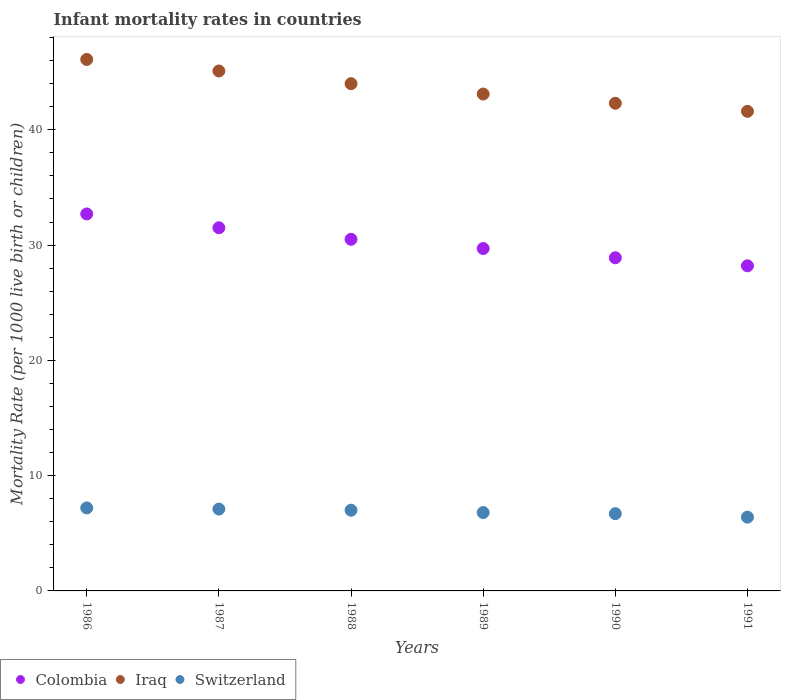What is the infant mortality rate in Colombia in 1987?
Your response must be concise. 31.5. Across all years, what is the maximum infant mortality rate in Iraq?
Give a very brief answer. 46.1. Across all years, what is the minimum infant mortality rate in Iraq?
Provide a succinct answer. 41.6. In which year was the infant mortality rate in Colombia maximum?
Offer a terse response. 1986. In which year was the infant mortality rate in Iraq minimum?
Provide a short and direct response. 1991. What is the total infant mortality rate in Switzerland in the graph?
Offer a very short reply. 41.2. What is the difference between the infant mortality rate in Iraq in 1988 and that in 1991?
Your answer should be very brief. 2.4. What is the difference between the infant mortality rate in Switzerland in 1986 and the infant mortality rate in Colombia in 1990?
Make the answer very short. -21.7. What is the average infant mortality rate in Switzerland per year?
Keep it short and to the point. 6.87. In the year 1989, what is the difference between the infant mortality rate in Colombia and infant mortality rate in Iraq?
Your answer should be very brief. -13.4. What is the ratio of the infant mortality rate in Colombia in 1986 to that in 1987?
Provide a short and direct response. 1.04. Is the infant mortality rate in Iraq in 1986 less than that in 1990?
Keep it short and to the point. No. Is the difference between the infant mortality rate in Colombia in 1986 and 1990 greater than the difference between the infant mortality rate in Iraq in 1986 and 1990?
Make the answer very short. No. What is the difference between the highest and the second highest infant mortality rate in Colombia?
Provide a succinct answer. 1.2. What is the difference between the highest and the lowest infant mortality rate in Switzerland?
Offer a very short reply. 0.8. In how many years, is the infant mortality rate in Colombia greater than the average infant mortality rate in Colombia taken over all years?
Your response must be concise. 3. Is it the case that in every year, the sum of the infant mortality rate in Iraq and infant mortality rate in Colombia  is greater than the infant mortality rate in Switzerland?
Make the answer very short. Yes. What is the difference between two consecutive major ticks on the Y-axis?
Make the answer very short. 10. Does the graph contain any zero values?
Your answer should be compact. No. Does the graph contain grids?
Offer a terse response. No. What is the title of the graph?
Your answer should be very brief. Infant mortality rates in countries. Does "French Polynesia" appear as one of the legend labels in the graph?
Your response must be concise. No. What is the label or title of the X-axis?
Your answer should be compact. Years. What is the label or title of the Y-axis?
Make the answer very short. Mortality Rate (per 1000 live birth or children). What is the Mortality Rate (per 1000 live birth or children) of Colombia in 1986?
Offer a terse response. 32.7. What is the Mortality Rate (per 1000 live birth or children) of Iraq in 1986?
Your response must be concise. 46.1. What is the Mortality Rate (per 1000 live birth or children) of Colombia in 1987?
Provide a succinct answer. 31.5. What is the Mortality Rate (per 1000 live birth or children) of Iraq in 1987?
Your response must be concise. 45.1. What is the Mortality Rate (per 1000 live birth or children) of Switzerland in 1987?
Your answer should be very brief. 7.1. What is the Mortality Rate (per 1000 live birth or children) of Colombia in 1988?
Give a very brief answer. 30.5. What is the Mortality Rate (per 1000 live birth or children) in Switzerland in 1988?
Ensure brevity in your answer.  7. What is the Mortality Rate (per 1000 live birth or children) of Colombia in 1989?
Make the answer very short. 29.7. What is the Mortality Rate (per 1000 live birth or children) of Iraq in 1989?
Your answer should be compact. 43.1. What is the Mortality Rate (per 1000 live birth or children) of Colombia in 1990?
Keep it short and to the point. 28.9. What is the Mortality Rate (per 1000 live birth or children) of Iraq in 1990?
Offer a terse response. 42.3. What is the Mortality Rate (per 1000 live birth or children) of Colombia in 1991?
Provide a short and direct response. 28.2. What is the Mortality Rate (per 1000 live birth or children) in Iraq in 1991?
Make the answer very short. 41.6. Across all years, what is the maximum Mortality Rate (per 1000 live birth or children) of Colombia?
Your answer should be very brief. 32.7. Across all years, what is the maximum Mortality Rate (per 1000 live birth or children) in Iraq?
Your answer should be compact. 46.1. Across all years, what is the minimum Mortality Rate (per 1000 live birth or children) of Colombia?
Give a very brief answer. 28.2. Across all years, what is the minimum Mortality Rate (per 1000 live birth or children) in Iraq?
Your answer should be compact. 41.6. Across all years, what is the minimum Mortality Rate (per 1000 live birth or children) of Switzerland?
Your response must be concise. 6.4. What is the total Mortality Rate (per 1000 live birth or children) of Colombia in the graph?
Offer a very short reply. 181.5. What is the total Mortality Rate (per 1000 live birth or children) of Iraq in the graph?
Make the answer very short. 262.2. What is the total Mortality Rate (per 1000 live birth or children) in Switzerland in the graph?
Provide a succinct answer. 41.2. What is the difference between the Mortality Rate (per 1000 live birth or children) in Switzerland in 1986 and that in 1987?
Your answer should be very brief. 0.1. What is the difference between the Mortality Rate (per 1000 live birth or children) of Colombia in 1986 and that in 1988?
Your answer should be compact. 2.2. What is the difference between the Mortality Rate (per 1000 live birth or children) of Iraq in 1986 and that in 1988?
Offer a very short reply. 2.1. What is the difference between the Mortality Rate (per 1000 live birth or children) of Switzerland in 1986 and that in 1988?
Keep it short and to the point. 0.2. What is the difference between the Mortality Rate (per 1000 live birth or children) in Switzerland in 1986 and that in 1990?
Provide a succinct answer. 0.5. What is the difference between the Mortality Rate (per 1000 live birth or children) of Iraq in 1986 and that in 1991?
Give a very brief answer. 4.5. What is the difference between the Mortality Rate (per 1000 live birth or children) of Switzerland in 1986 and that in 1991?
Keep it short and to the point. 0.8. What is the difference between the Mortality Rate (per 1000 live birth or children) of Iraq in 1987 and that in 1988?
Provide a succinct answer. 1.1. What is the difference between the Mortality Rate (per 1000 live birth or children) in Switzerland in 1987 and that in 1988?
Provide a short and direct response. 0.1. What is the difference between the Mortality Rate (per 1000 live birth or children) of Colombia in 1987 and that in 1989?
Offer a terse response. 1.8. What is the difference between the Mortality Rate (per 1000 live birth or children) of Iraq in 1987 and that in 1990?
Provide a short and direct response. 2.8. What is the difference between the Mortality Rate (per 1000 live birth or children) in Switzerland in 1987 and that in 1990?
Your response must be concise. 0.4. What is the difference between the Mortality Rate (per 1000 live birth or children) of Colombia in 1987 and that in 1991?
Offer a terse response. 3.3. What is the difference between the Mortality Rate (per 1000 live birth or children) of Iraq in 1987 and that in 1991?
Ensure brevity in your answer.  3.5. What is the difference between the Mortality Rate (per 1000 live birth or children) in Switzerland in 1987 and that in 1991?
Your answer should be very brief. 0.7. What is the difference between the Mortality Rate (per 1000 live birth or children) of Iraq in 1988 and that in 1991?
Give a very brief answer. 2.4. What is the difference between the Mortality Rate (per 1000 live birth or children) in Colombia in 1989 and that in 1991?
Keep it short and to the point. 1.5. What is the difference between the Mortality Rate (per 1000 live birth or children) in Iraq in 1989 and that in 1991?
Keep it short and to the point. 1.5. What is the difference between the Mortality Rate (per 1000 live birth or children) of Switzerland in 1989 and that in 1991?
Offer a very short reply. 0.4. What is the difference between the Mortality Rate (per 1000 live birth or children) in Iraq in 1990 and that in 1991?
Ensure brevity in your answer.  0.7. What is the difference between the Mortality Rate (per 1000 live birth or children) of Colombia in 1986 and the Mortality Rate (per 1000 live birth or children) of Iraq in 1987?
Make the answer very short. -12.4. What is the difference between the Mortality Rate (per 1000 live birth or children) of Colombia in 1986 and the Mortality Rate (per 1000 live birth or children) of Switzerland in 1987?
Provide a succinct answer. 25.6. What is the difference between the Mortality Rate (per 1000 live birth or children) in Colombia in 1986 and the Mortality Rate (per 1000 live birth or children) in Iraq in 1988?
Provide a short and direct response. -11.3. What is the difference between the Mortality Rate (per 1000 live birth or children) in Colombia in 1986 and the Mortality Rate (per 1000 live birth or children) in Switzerland in 1988?
Provide a short and direct response. 25.7. What is the difference between the Mortality Rate (per 1000 live birth or children) in Iraq in 1986 and the Mortality Rate (per 1000 live birth or children) in Switzerland in 1988?
Your response must be concise. 39.1. What is the difference between the Mortality Rate (per 1000 live birth or children) in Colombia in 1986 and the Mortality Rate (per 1000 live birth or children) in Iraq in 1989?
Ensure brevity in your answer.  -10.4. What is the difference between the Mortality Rate (per 1000 live birth or children) of Colombia in 1986 and the Mortality Rate (per 1000 live birth or children) of Switzerland in 1989?
Ensure brevity in your answer.  25.9. What is the difference between the Mortality Rate (per 1000 live birth or children) of Iraq in 1986 and the Mortality Rate (per 1000 live birth or children) of Switzerland in 1989?
Offer a very short reply. 39.3. What is the difference between the Mortality Rate (per 1000 live birth or children) of Iraq in 1986 and the Mortality Rate (per 1000 live birth or children) of Switzerland in 1990?
Your response must be concise. 39.4. What is the difference between the Mortality Rate (per 1000 live birth or children) in Colombia in 1986 and the Mortality Rate (per 1000 live birth or children) in Iraq in 1991?
Give a very brief answer. -8.9. What is the difference between the Mortality Rate (per 1000 live birth or children) of Colombia in 1986 and the Mortality Rate (per 1000 live birth or children) of Switzerland in 1991?
Your answer should be compact. 26.3. What is the difference between the Mortality Rate (per 1000 live birth or children) in Iraq in 1986 and the Mortality Rate (per 1000 live birth or children) in Switzerland in 1991?
Your answer should be very brief. 39.7. What is the difference between the Mortality Rate (per 1000 live birth or children) in Colombia in 1987 and the Mortality Rate (per 1000 live birth or children) in Iraq in 1988?
Offer a terse response. -12.5. What is the difference between the Mortality Rate (per 1000 live birth or children) of Iraq in 1987 and the Mortality Rate (per 1000 live birth or children) of Switzerland in 1988?
Offer a very short reply. 38.1. What is the difference between the Mortality Rate (per 1000 live birth or children) in Colombia in 1987 and the Mortality Rate (per 1000 live birth or children) in Switzerland in 1989?
Provide a succinct answer. 24.7. What is the difference between the Mortality Rate (per 1000 live birth or children) in Iraq in 1987 and the Mortality Rate (per 1000 live birth or children) in Switzerland in 1989?
Give a very brief answer. 38.3. What is the difference between the Mortality Rate (per 1000 live birth or children) in Colombia in 1987 and the Mortality Rate (per 1000 live birth or children) in Switzerland in 1990?
Keep it short and to the point. 24.8. What is the difference between the Mortality Rate (per 1000 live birth or children) in Iraq in 1987 and the Mortality Rate (per 1000 live birth or children) in Switzerland in 1990?
Provide a short and direct response. 38.4. What is the difference between the Mortality Rate (per 1000 live birth or children) of Colombia in 1987 and the Mortality Rate (per 1000 live birth or children) of Iraq in 1991?
Provide a succinct answer. -10.1. What is the difference between the Mortality Rate (per 1000 live birth or children) in Colombia in 1987 and the Mortality Rate (per 1000 live birth or children) in Switzerland in 1991?
Keep it short and to the point. 25.1. What is the difference between the Mortality Rate (per 1000 live birth or children) in Iraq in 1987 and the Mortality Rate (per 1000 live birth or children) in Switzerland in 1991?
Keep it short and to the point. 38.7. What is the difference between the Mortality Rate (per 1000 live birth or children) in Colombia in 1988 and the Mortality Rate (per 1000 live birth or children) in Iraq in 1989?
Your answer should be very brief. -12.6. What is the difference between the Mortality Rate (per 1000 live birth or children) of Colombia in 1988 and the Mortality Rate (per 1000 live birth or children) of Switzerland in 1989?
Provide a succinct answer. 23.7. What is the difference between the Mortality Rate (per 1000 live birth or children) in Iraq in 1988 and the Mortality Rate (per 1000 live birth or children) in Switzerland in 1989?
Provide a short and direct response. 37.2. What is the difference between the Mortality Rate (per 1000 live birth or children) in Colombia in 1988 and the Mortality Rate (per 1000 live birth or children) in Switzerland in 1990?
Give a very brief answer. 23.8. What is the difference between the Mortality Rate (per 1000 live birth or children) of Iraq in 1988 and the Mortality Rate (per 1000 live birth or children) of Switzerland in 1990?
Provide a short and direct response. 37.3. What is the difference between the Mortality Rate (per 1000 live birth or children) of Colombia in 1988 and the Mortality Rate (per 1000 live birth or children) of Iraq in 1991?
Your response must be concise. -11.1. What is the difference between the Mortality Rate (per 1000 live birth or children) in Colombia in 1988 and the Mortality Rate (per 1000 live birth or children) in Switzerland in 1991?
Your answer should be compact. 24.1. What is the difference between the Mortality Rate (per 1000 live birth or children) in Iraq in 1988 and the Mortality Rate (per 1000 live birth or children) in Switzerland in 1991?
Provide a short and direct response. 37.6. What is the difference between the Mortality Rate (per 1000 live birth or children) in Iraq in 1989 and the Mortality Rate (per 1000 live birth or children) in Switzerland in 1990?
Your response must be concise. 36.4. What is the difference between the Mortality Rate (per 1000 live birth or children) in Colombia in 1989 and the Mortality Rate (per 1000 live birth or children) in Switzerland in 1991?
Your answer should be very brief. 23.3. What is the difference between the Mortality Rate (per 1000 live birth or children) in Iraq in 1989 and the Mortality Rate (per 1000 live birth or children) in Switzerland in 1991?
Keep it short and to the point. 36.7. What is the difference between the Mortality Rate (per 1000 live birth or children) in Colombia in 1990 and the Mortality Rate (per 1000 live birth or children) in Iraq in 1991?
Offer a terse response. -12.7. What is the difference between the Mortality Rate (per 1000 live birth or children) in Iraq in 1990 and the Mortality Rate (per 1000 live birth or children) in Switzerland in 1991?
Offer a very short reply. 35.9. What is the average Mortality Rate (per 1000 live birth or children) of Colombia per year?
Offer a very short reply. 30.25. What is the average Mortality Rate (per 1000 live birth or children) in Iraq per year?
Offer a terse response. 43.7. What is the average Mortality Rate (per 1000 live birth or children) of Switzerland per year?
Your answer should be compact. 6.87. In the year 1986, what is the difference between the Mortality Rate (per 1000 live birth or children) of Colombia and Mortality Rate (per 1000 live birth or children) of Switzerland?
Keep it short and to the point. 25.5. In the year 1986, what is the difference between the Mortality Rate (per 1000 live birth or children) of Iraq and Mortality Rate (per 1000 live birth or children) of Switzerland?
Your answer should be very brief. 38.9. In the year 1987, what is the difference between the Mortality Rate (per 1000 live birth or children) of Colombia and Mortality Rate (per 1000 live birth or children) of Switzerland?
Offer a terse response. 24.4. In the year 1988, what is the difference between the Mortality Rate (per 1000 live birth or children) in Colombia and Mortality Rate (per 1000 live birth or children) in Iraq?
Provide a succinct answer. -13.5. In the year 1989, what is the difference between the Mortality Rate (per 1000 live birth or children) in Colombia and Mortality Rate (per 1000 live birth or children) in Switzerland?
Your answer should be compact. 22.9. In the year 1989, what is the difference between the Mortality Rate (per 1000 live birth or children) in Iraq and Mortality Rate (per 1000 live birth or children) in Switzerland?
Give a very brief answer. 36.3. In the year 1990, what is the difference between the Mortality Rate (per 1000 live birth or children) in Colombia and Mortality Rate (per 1000 live birth or children) in Iraq?
Provide a short and direct response. -13.4. In the year 1990, what is the difference between the Mortality Rate (per 1000 live birth or children) of Colombia and Mortality Rate (per 1000 live birth or children) of Switzerland?
Your answer should be very brief. 22.2. In the year 1990, what is the difference between the Mortality Rate (per 1000 live birth or children) in Iraq and Mortality Rate (per 1000 live birth or children) in Switzerland?
Ensure brevity in your answer.  35.6. In the year 1991, what is the difference between the Mortality Rate (per 1000 live birth or children) of Colombia and Mortality Rate (per 1000 live birth or children) of Iraq?
Give a very brief answer. -13.4. In the year 1991, what is the difference between the Mortality Rate (per 1000 live birth or children) in Colombia and Mortality Rate (per 1000 live birth or children) in Switzerland?
Your answer should be very brief. 21.8. In the year 1991, what is the difference between the Mortality Rate (per 1000 live birth or children) in Iraq and Mortality Rate (per 1000 live birth or children) in Switzerland?
Ensure brevity in your answer.  35.2. What is the ratio of the Mortality Rate (per 1000 live birth or children) in Colombia in 1986 to that in 1987?
Make the answer very short. 1.04. What is the ratio of the Mortality Rate (per 1000 live birth or children) of Iraq in 1986 to that in 1987?
Keep it short and to the point. 1.02. What is the ratio of the Mortality Rate (per 1000 live birth or children) of Switzerland in 1986 to that in 1987?
Your answer should be compact. 1.01. What is the ratio of the Mortality Rate (per 1000 live birth or children) in Colombia in 1986 to that in 1988?
Give a very brief answer. 1.07. What is the ratio of the Mortality Rate (per 1000 live birth or children) of Iraq in 1986 to that in 1988?
Keep it short and to the point. 1.05. What is the ratio of the Mortality Rate (per 1000 live birth or children) in Switzerland in 1986 to that in 1988?
Your response must be concise. 1.03. What is the ratio of the Mortality Rate (per 1000 live birth or children) in Colombia in 1986 to that in 1989?
Give a very brief answer. 1.1. What is the ratio of the Mortality Rate (per 1000 live birth or children) of Iraq in 1986 to that in 1989?
Ensure brevity in your answer.  1.07. What is the ratio of the Mortality Rate (per 1000 live birth or children) in Switzerland in 1986 to that in 1989?
Make the answer very short. 1.06. What is the ratio of the Mortality Rate (per 1000 live birth or children) of Colombia in 1986 to that in 1990?
Ensure brevity in your answer.  1.13. What is the ratio of the Mortality Rate (per 1000 live birth or children) in Iraq in 1986 to that in 1990?
Ensure brevity in your answer.  1.09. What is the ratio of the Mortality Rate (per 1000 live birth or children) in Switzerland in 1986 to that in 1990?
Ensure brevity in your answer.  1.07. What is the ratio of the Mortality Rate (per 1000 live birth or children) of Colombia in 1986 to that in 1991?
Ensure brevity in your answer.  1.16. What is the ratio of the Mortality Rate (per 1000 live birth or children) of Iraq in 1986 to that in 1991?
Give a very brief answer. 1.11. What is the ratio of the Mortality Rate (per 1000 live birth or children) in Colombia in 1987 to that in 1988?
Make the answer very short. 1.03. What is the ratio of the Mortality Rate (per 1000 live birth or children) in Iraq in 1987 to that in 1988?
Offer a terse response. 1.02. What is the ratio of the Mortality Rate (per 1000 live birth or children) of Switzerland in 1987 to that in 1988?
Make the answer very short. 1.01. What is the ratio of the Mortality Rate (per 1000 live birth or children) in Colombia in 1987 to that in 1989?
Your response must be concise. 1.06. What is the ratio of the Mortality Rate (per 1000 live birth or children) in Iraq in 1987 to that in 1989?
Provide a short and direct response. 1.05. What is the ratio of the Mortality Rate (per 1000 live birth or children) in Switzerland in 1987 to that in 1989?
Your answer should be very brief. 1.04. What is the ratio of the Mortality Rate (per 1000 live birth or children) of Colombia in 1987 to that in 1990?
Your answer should be very brief. 1.09. What is the ratio of the Mortality Rate (per 1000 live birth or children) in Iraq in 1987 to that in 1990?
Make the answer very short. 1.07. What is the ratio of the Mortality Rate (per 1000 live birth or children) of Switzerland in 1987 to that in 1990?
Offer a terse response. 1.06. What is the ratio of the Mortality Rate (per 1000 live birth or children) in Colombia in 1987 to that in 1991?
Keep it short and to the point. 1.12. What is the ratio of the Mortality Rate (per 1000 live birth or children) in Iraq in 1987 to that in 1991?
Provide a short and direct response. 1.08. What is the ratio of the Mortality Rate (per 1000 live birth or children) in Switzerland in 1987 to that in 1991?
Keep it short and to the point. 1.11. What is the ratio of the Mortality Rate (per 1000 live birth or children) in Colombia in 1988 to that in 1989?
Provide a short and direct response. 1.03. What is the ratio of the Mortality Rate (per 1000 live birth or children) in Iraq in 1988 to that in 1989?
Make the answer very short. 1.02. What is the ratio of the Mortality Rate (per 1000 live birth or children) in Switzerland in 1988 to that in 1989?
Make the answer very short. 1.03. What is the ratio of the Mortality Rate (per 1000 live birth or children) of Colombia in 1988 to that in 1990?
Your answer should be very brief. 1.06. What is the ratio of the Mortality Rate (per 1000 live birth or children) of Iraq in 1988 to that in 1990?
Give a very brief answer. 1.04. What is the ratio of the Mortality Rate (per 1000 live birth or children) in Switzerland in 1988 to that in 1990?
Offer a terse response. 1.04. What is the ratio of the Mortality Rate (per 1000 live birth or children) of Colombia in 1988 to that in 1991?
Give a very brief answer. 1.08. What is the ratio of the Mortality Rate (per 1000 live birth or children) of Iraq in 1988 to that in 1991?
Make the answer very short. 1.06. What is the ratio of the Mortality Rate (per 1000 live birth or children) of Switzerland in 1988 to that in 1991?
Make the answer very short. 1.09. What is the ratio of the Mortality Rate (per 1000 live birth or children) in Colombia in 1989 to that in 1990?
Keep it short and to the point. 1.03. What is the ratio of the Mortality Rate (per 1000 live birth or children) in Iraq in 1989 to that in 1990?
Keep it short and to the point. 1.02. What is the ratio of the Mortality Rate (per 1000 live birth or children) of Switzerland in 1989 to that in 1990?
Provide a short and direct response. 1.01. What is the ratio of the Mortality Rate (per 1000 live birth or children) of Colombia in 1989 to that in 1991?
Offer a very short reply. 1.05. What is the ratio of the Mortality Rate (per 1000 live birth or children) of Iraq in 1989 to that in 1991?
Give a very brief answer. 1.04. What is the ratio of the Mortality Rate (per 1000 live birth or children) of Switzerland in 1989 to that in 1991?
Provide a short and direct response. 1.06. What is the ratio of the Mortality Rate (per 1000 live birth or children) of Colombia in 1990 to that in 1991?
Your response must be concise. 1.02. What is the ratio of the Mortality Rate (per 1000 live birth or children) of Iraq in 1990 to that in 1991?
Provide a succinct answer. 1.02. What is the ratio of the Mortality Rate (per 1000 live birth or children) in Switzerland in 1990 to that in 1991?
Your answer should be very brief. 1.05. What is the difference between the highest and the second highest Mortality Rate (per 1000 live birth or children) in Colombia?
Keep it short and to the point. 1.2. What is the difference between the highest and the lowest Mortality Rate (per 1000 live birth or children) of Iraq?
Your answer should be compact. 4.5. What is the difference between the highest and the lowest Mortality Rate (per 1000 live birth or children) in Switzerland?
Ensure brevity in your answer.  0.8. 